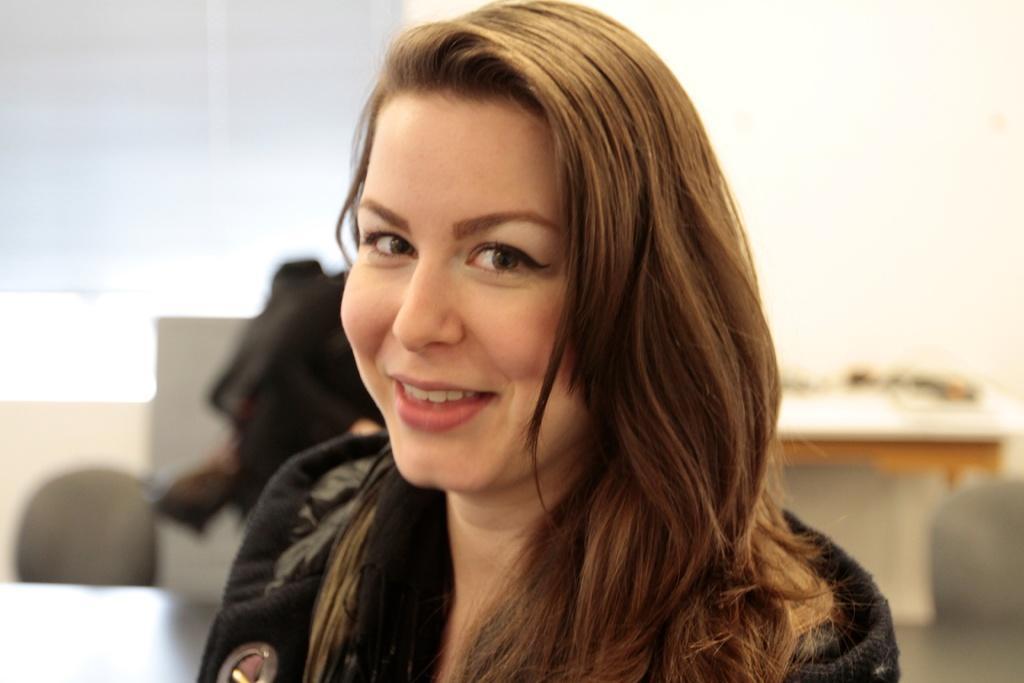How would you summarize this image in a sentence or two? Here I can see a woman smiling and looking at the picture. On the right side there is a table. At the back of this woman there is another person and there are few objects. The background is blurred. 